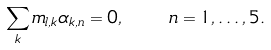<formula> <loc_0><loc_0><loc_500><loc_500>\sum _ { k } m _ { l , k } \alpha _ { k , n } = 0 , \quad n = 1 , \dots , 5 .</formula> 